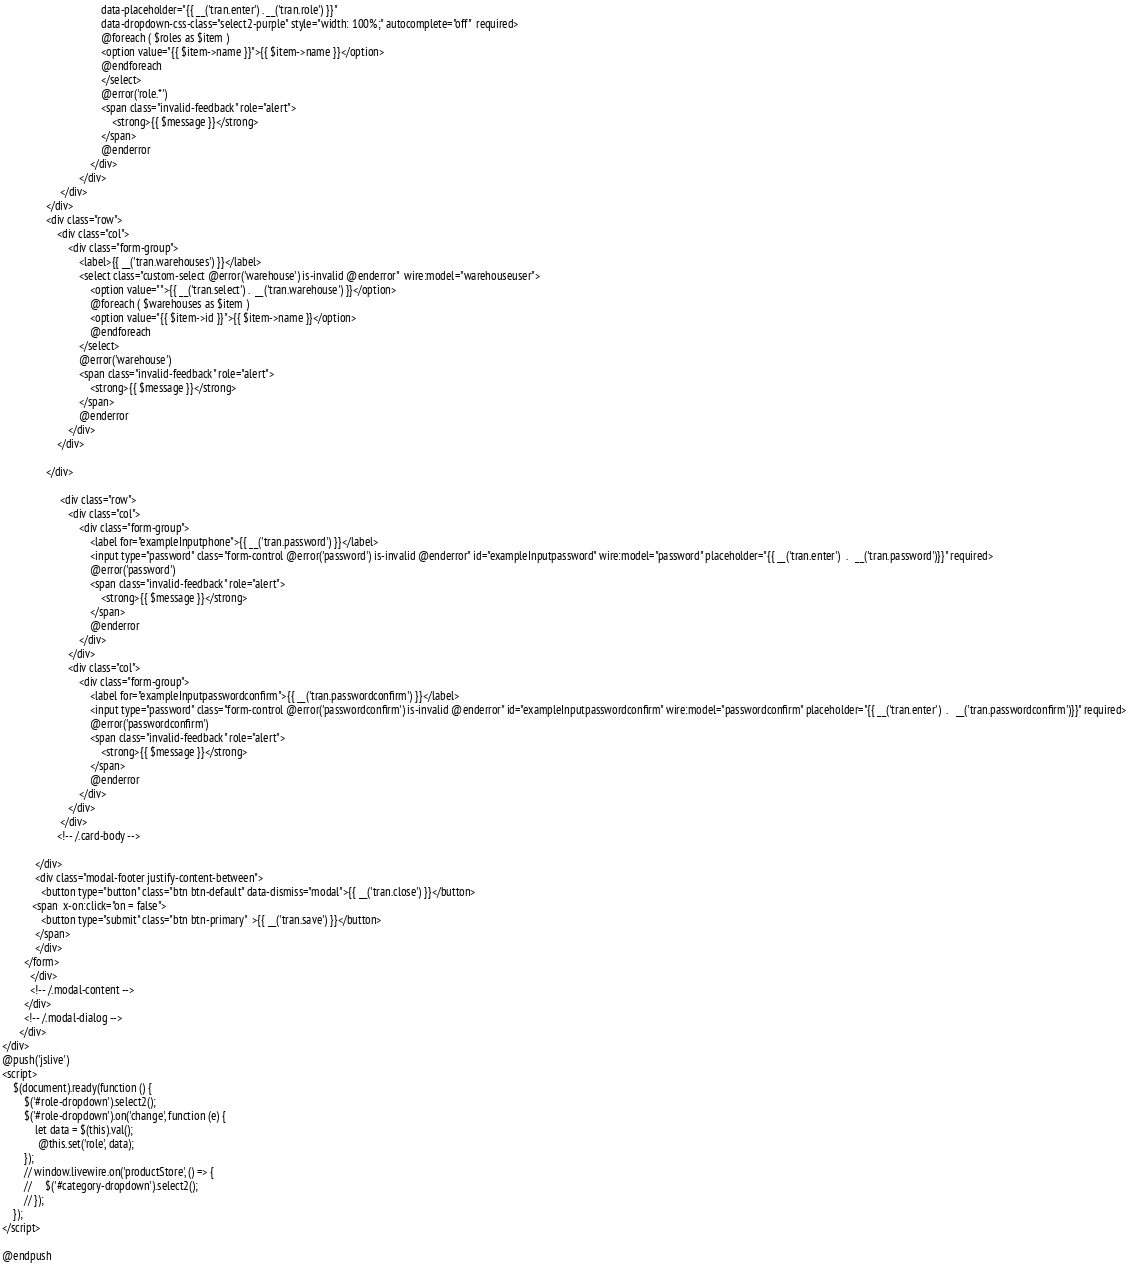Convert code to text. <code><loc_0><loc_0><loc_500><loc_500><_PHP_>                                    data-placeholder="{{ __('tran.enter') . __('tran.role') }}"
                                    data-dropdown-css-class="select2-purple" style="width: 100%;" autocomplete="off"  required>
                                    @foreach ( $roles as $item )
                                    <option value="{{ $item->name }}">{{ $item->name }}</option>
                                    @endforeach
                                    </select>
                                    @error('role.*')
                                    <span class="invalid-feedback" role="alert">
                                        <strong>{{ $message }}</strong>
                                    </span>
                                    @enderror
                                </div>
                            </div>
                     </div>
                </div>
                <div class="row">
                    <div class="col">
                        <div class="form-group">
                            <label>{{ __('tran.warehouses') }}</label>
                            <select class="custom-select @error('warehouse') is-invalid @enderror"  wire:model="warehouseuser">
                                <option value="">{{ __('tran.select') .  __('tran.warehouse') }}</option>
                                @foreach ( $warehouses as $item )
                                <option value="{{ $item->id }}">{{ $item->name }}</option>
                                @endforeach
                            </select>
                            @error('warehouse')
                            <span class="invalid-feedback" role="alert">
                                <strong>{{ $message }}</strong>
                            </span>
                            @enderror
                        </div>
                    </div>

                </div>

                     <div class="row">
                        <div class="col">
                            <div class="form-group">
                                <label for="exampleInputphone">{{ __('tran.password') }}</label>
                                <input type="password" class="form-control @error('password') is-invalid @enderror" id="exampleInputpassword" wire:model="password" placeholder="{{ __('tran.enter')  .   __('tran.password')}}" required>
                                @error('password')
                                <span class="invalid-feedback" role="alert">
                                    <strong>{{ $message }}</strong>
                                </span>
                                @enderror
                            </div>
                        </div>
                        <div class="col">
                            <div class="form-group">
                                <label for="exampleInputpasswordconfirm">{{ __('tran.passwordconfirm') }}</label>
                                <input type="password" class="form-control @error('passwordconfirm') is-invalid @enderror" id="exampleInputpasswordconfirm" wire:model="passwordconfirm" placeholder="{{ __('tran.enter')  .   __('tran.passwordconfirm')}}" required>
                                @error('passwordconfirm')
                                <span class="invalid-feedback" role="alert">
                                    <strong>{{ $message }}</strong>
                                </span>
                                @enderror
                            </div>
                        </div>
                     </div>
                    <!-- /.card-body -->

            </div>
            <div class="modal-footer justify-content-between">
              <button type="button" class="btn btn-default" data-dismiss="modal">{{ __('tran.close') }}</button>
           <span  x-on:click="on = false">
              <button type="submit" class="btn btn-primary"  >{{ __('tran.save') }}</button>
            </span>
            </div>
        </form>
          </div>
          <!-- /.modal-content -->
        </div>
        <!-- /.modal-dialog -->
      </div>
</div>
@push('jslive')
<script>
    $(document).ready(function () {
        $('#role-dropdown').select2();
        $('#role-dropdown').on('change', function (e) {
            let data = $(this).val();
             @this.set('role', data);
        });
        // window.livewire.on('productStore', () => {
        //     $('#category-dropdown').select2();
        // });
    });
</script>

@endpush
</code> 